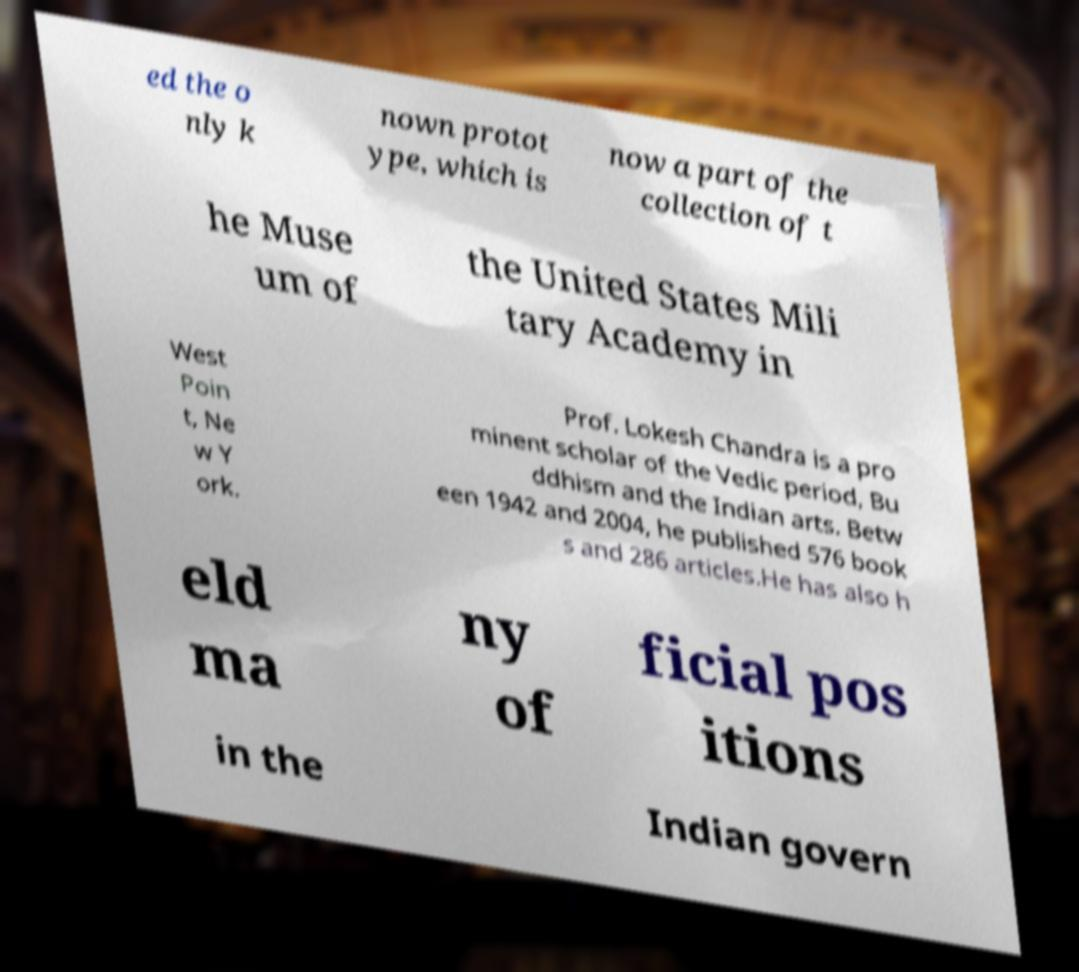Please identify and transcribe the text found in this image. ed the o nly k nown protot ype, which is now a part of the collection of t he Muse um of the United States Mili tary Academy in West Poin t, Ne w Y ork. Prof. Lokesh Chandra is a pro minent scholar of the Vedic period, Bu ddhism and the Indian arts. Betw een 1942 and 2004, he published 576 book s and 286 articles.He has also h eld ma ny of ficial pos itions in the Indian govern 